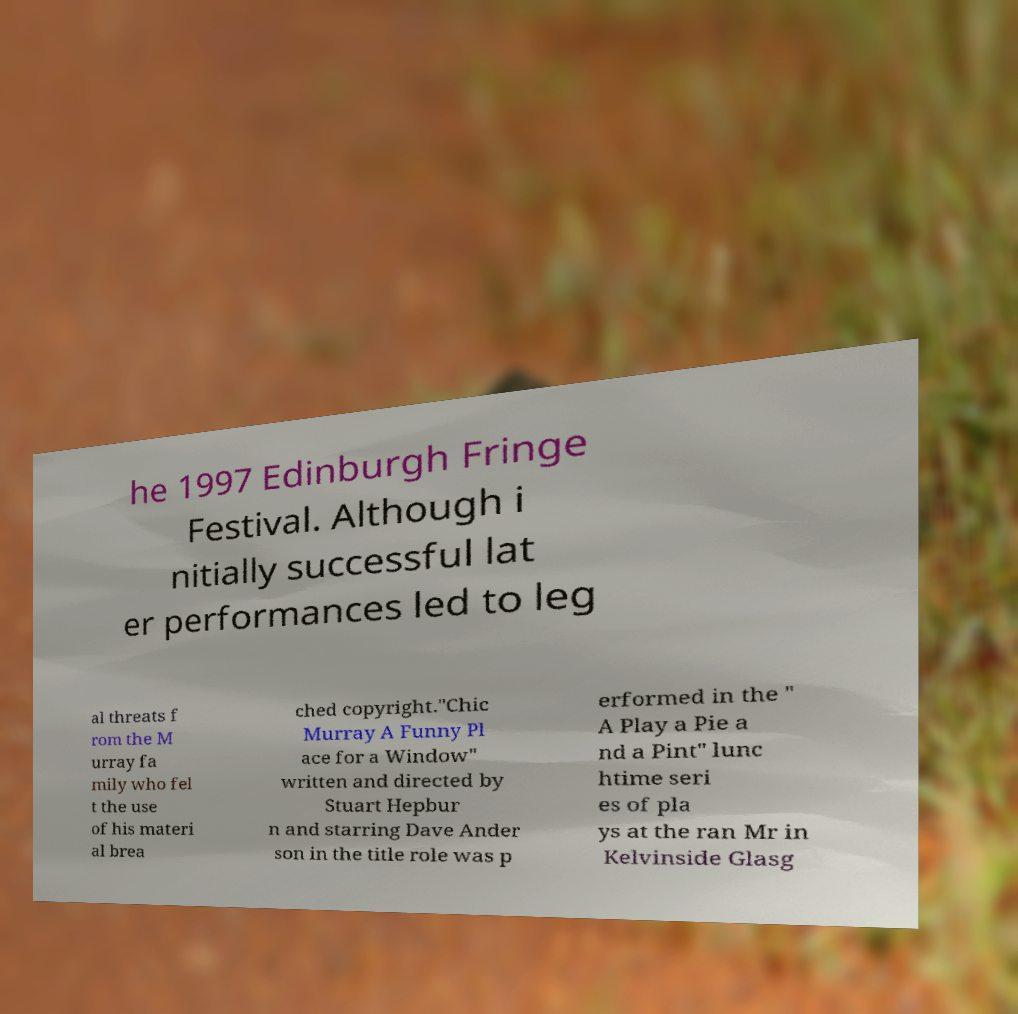Could you extract and type out the text from this image? he 1997 Edinburgh Fringe Festival. Although i nitially successful lat er performances led to leg al threats f rom the M urray fa mily who fel t the use of his materi al brea ched copyright."Chic Murray A Funny Pl ace for a Window" written and directed by Stuart Hepbur n and starring Dave Ander son in the title role was p erformed in the " A Play a Pie a nd a Pint" lunc htime seri es of pla ys at the ran Mr in Kelvinside Glasg 